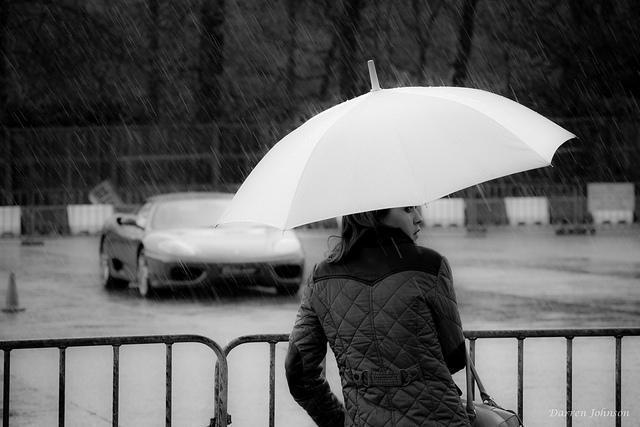Does the image validate the caption "The person is under the umbrella."?
Answer yes or no. Yes. 